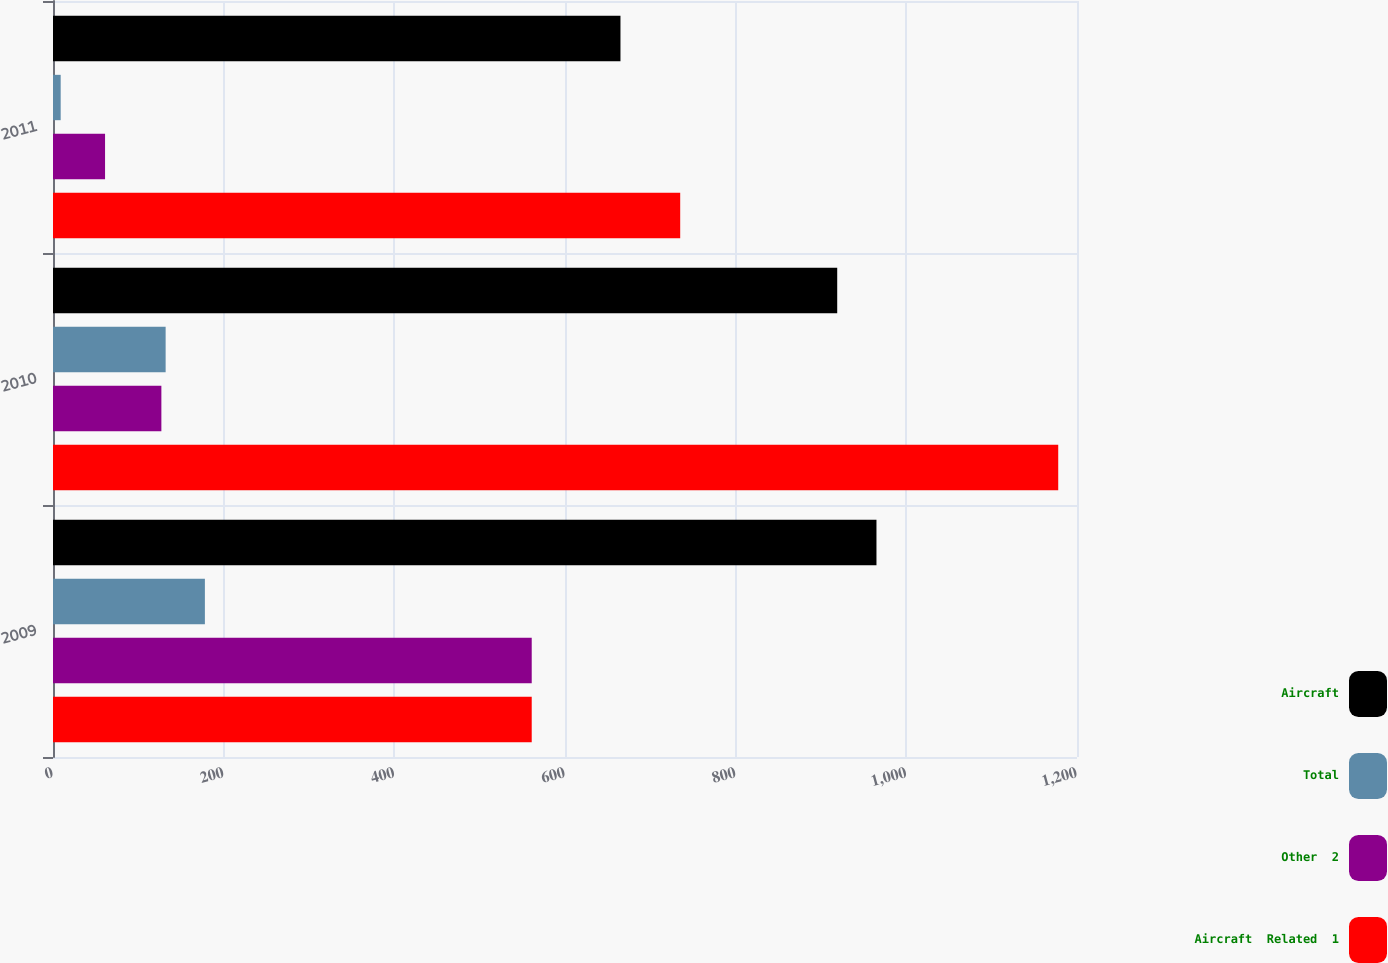Convert chart to OTSL. <chart><loc_0><loc_0><loc_500><loc_500><stacked_bar_chart><ecel><fcel>2009<fcel>2010<fcel>2011<nl><fcel>Aircraft<fcel>965<fcel>919<fcel>665<nl><fcel>Total<fcel>178<fcel>132<fcel>9<nl><fcel>Other  2<fcel>561<fcel>127<fcel>61<nl><fcel>Aircraft  Related  1<fcel>561<fcel>1178<fcel>735<nl></chart> 